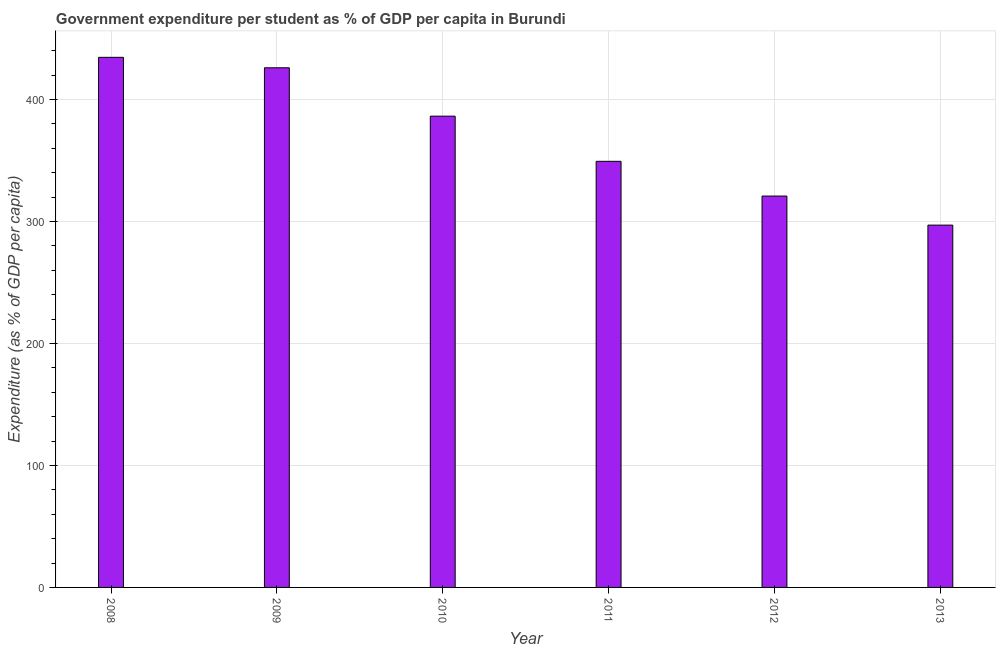Does the graph contain any zero values?
Your response must be concise. No. Does the graph contain grids?
Your answer should be compact. Yes. What is the title of the graph?
Keep it short and to the point. Government expenditure per student as % of GDP per capita in Burundi. What is the label or title of the X-axis?
Provide a succinct answer. Year. What is the label or title of the Y-axis?
Provide a succinct answer. Expenditure (as % of GDP per capita). What is the government expenditure per student in 2008?
Offer a very short reply. 434.66. Across all years, what is the maximum government expenditure per student?
Make the answer very short. 434.66. Across all years, what is the minimum government expenditure per student?
Give a very brief answer. 297.08. In which year was the government expenditure per student minimum?
Offer a very short reply. 2013. What is the sum of the government expenditure per student?
Ensure brevity in your answer.  2214.55. What is the difference between the government expenditure per student in 2009 and 2011?
Make the answer very short. 76.7. What is the average government expenditure per student per year?
Make the answer very short. 369.09. What is the median government expenditure per student?
Keep it short and to the point. 367.9. In how many years, is the government expenditure per student greater than 160 %?
Offer a very short reply. 6. Do a majority of the years between 2008 and 2011 (inclusive) have government expenditure per student greater than 180 %?
Your answer should be compact. Yes. What is the ratio of the government expenditure per student in 2009 to that in 2011?
Give a very brief answer. 1.22. Is the government expenditure per student in 2008 less than that in 2009?
Provide a succinct answer. No. What is the difference between the highest and the second highest government expenditure per student?
Provide a short and direct response. 8.58. Is the sum of the government expenditure per student in 2010 and 2012 greater than the maximum government expenditure per student across all years?
Keep it short and to the point. Yes. What is the difference between the highest and the lowest government expenditure per student?
Keep it short and to the point. 137.58. In how many years, is the government expenditure per student greater than the average government expenditure per student taken over all years?
Keep it short and to the point. 3. How many years are there in the graph?
Make the answer very short. 6. What is the difference between two consecutive major ticks on the Y-axis?
Keep it short and to the point. 100. What is the Expenditure (as % of GDP per capita) of 2008?
Provide a short and direct response. 434.66. What is the Expenditure (as % of GDP per capita) of 2009?
Give a very brief answer. 426.08. What is the Expenditure (as % of GDP per capita) in 2010?
Make the answer very short. 386.42. What is the Expenditure (as % of GDP per capita) in 2011?
Make the answer very short. 349.39. What is the Expenditure (as % of GDP per capita) in 2012?
Offer a terse response. 320.91. What is the Expenditure (as % of GDP per capita) in 2013?
Provide a short and direct response. 297.08. What is the difference between the Expenditure (as % of GDP per capita) in 2008 and 2009?
Provide a short and direct response. 8.58. What is the difference between the Expenditure (as % of GDP per capita) in 2008 and 2010?
Keep it short and to the point. 48.24. What is the difference between the Expenditure (as % of GDP per capita) in 2008 and 2011?
Your answer should be compact. 85.27. What is the difference between the Expenditure (as % of GDP per capita) in 2008 and 2012?
Your answer should be compact. 113.75. What is the difference between the Expenditure (as % of GDP per capita) in 2008 and 2013?
Your response must be concise. 137.58. What is the difference between the Expenditure (as % of GDP per capita) in 2009 and 2010?
Provide a short and direct response. 39.66. What is the difference between the Expenditure (as % of GDP per capita) in 2009 and 2011?
Give a very brief answer. 76.7. What is the difference between the Expenditure (as % of GDP per capita) in 2009 and 2012?
Your answer should be very brief. 105.17. What is the difference between the Expenditure (as % of GDP per capita) in 2009 and 2013?
Ensure brevity in your answer.  129. What is the difference between the Expenditure (as % of GDP per capita) in 2010 and 2011?
Make the answer very short. 37.03. What is the difference between the Expenditure (as % of GDP per capita) in 2010 and 2012?
Ensure brevity in your answer.  65.51. What is the difference between the Expenditure (as % of GDP per capita) in 2010 and 2013?
Your answer should be very brief. 89.34. What is the difference between the Expenditure (as % of GDP per capita) in 2011 and 2012?
Offer a very short reply. 28.47. What is the difference between the Expenditure (as % of GDP per capita) in 2011 and 2013?
Provide a short and direct response. 52.3. What is the difference between the Expenditure (as % of GDP per capita) in 2012 and 2013?
Keep it short and to the point. 23.83. What is the ratio of the Expenditure (as % of GDP per capita) in 2008 to that in 2009?
Offer a very short reply. 1.02. What is the ratio of the Expenditure (as % of GDP per capita) in 2008 to that in 2011?
Your answer should be very brief. 1.24. What is the ratio of the Expenditure (as % of GDP per capita) in 2008 to that in 2012?
Offer a terse response. 1.35. What is the ratio of the Expenditure (as % of GDP per capita) in 2008 to that in 2013?
Ensure brevity in your answer.  1.46. What is the ratio of the Expenditure (as % of GDP per capita) in 2009 to that in 2010?
Keep it short and to the point. 1.1. What is the ratio of the Expenditure (as % of GDP per capita) in 2009 to that in 2011?
Your response must be concise. 1.22. What is the ratio of the Expenditure (as % of GDP per capita) in 2009 to that in 2012?
Offer a very short reply. 1.33. What is the ratio of the Expenditure (as % of GDP per capita) in 2009 to that in 2013?
Give a very brief answer. 1.43. What is the ratio of the Expenditure (as % of GDP per capita) in 2010 to that in 2011?
Offer a terse response. 1.11. What is the ratio of the Expenditure (as % of GDP per capita) in 2010 to that in 2012?
Offer a very short reply. 1.2. What is the ratio of the Expenditure (as % of GDP per capita) in 2010 to that in 2013?
Provide a succinct answer. 1.3. What is the ratio of the Expenditure (as % of GDP per capita) in 2011 to that in 2012?
Ensure brevity in your answer.  1.09. What is the ratio of the Expenditure (as % of GDP per capita) in 2011 to that in 2013?
Offer a terse response. 1.18. What is the ratio of the Expenditure (as % of GDP per capita) in 2012 to that in 2013?
Your answer should be compact. 1.08. 